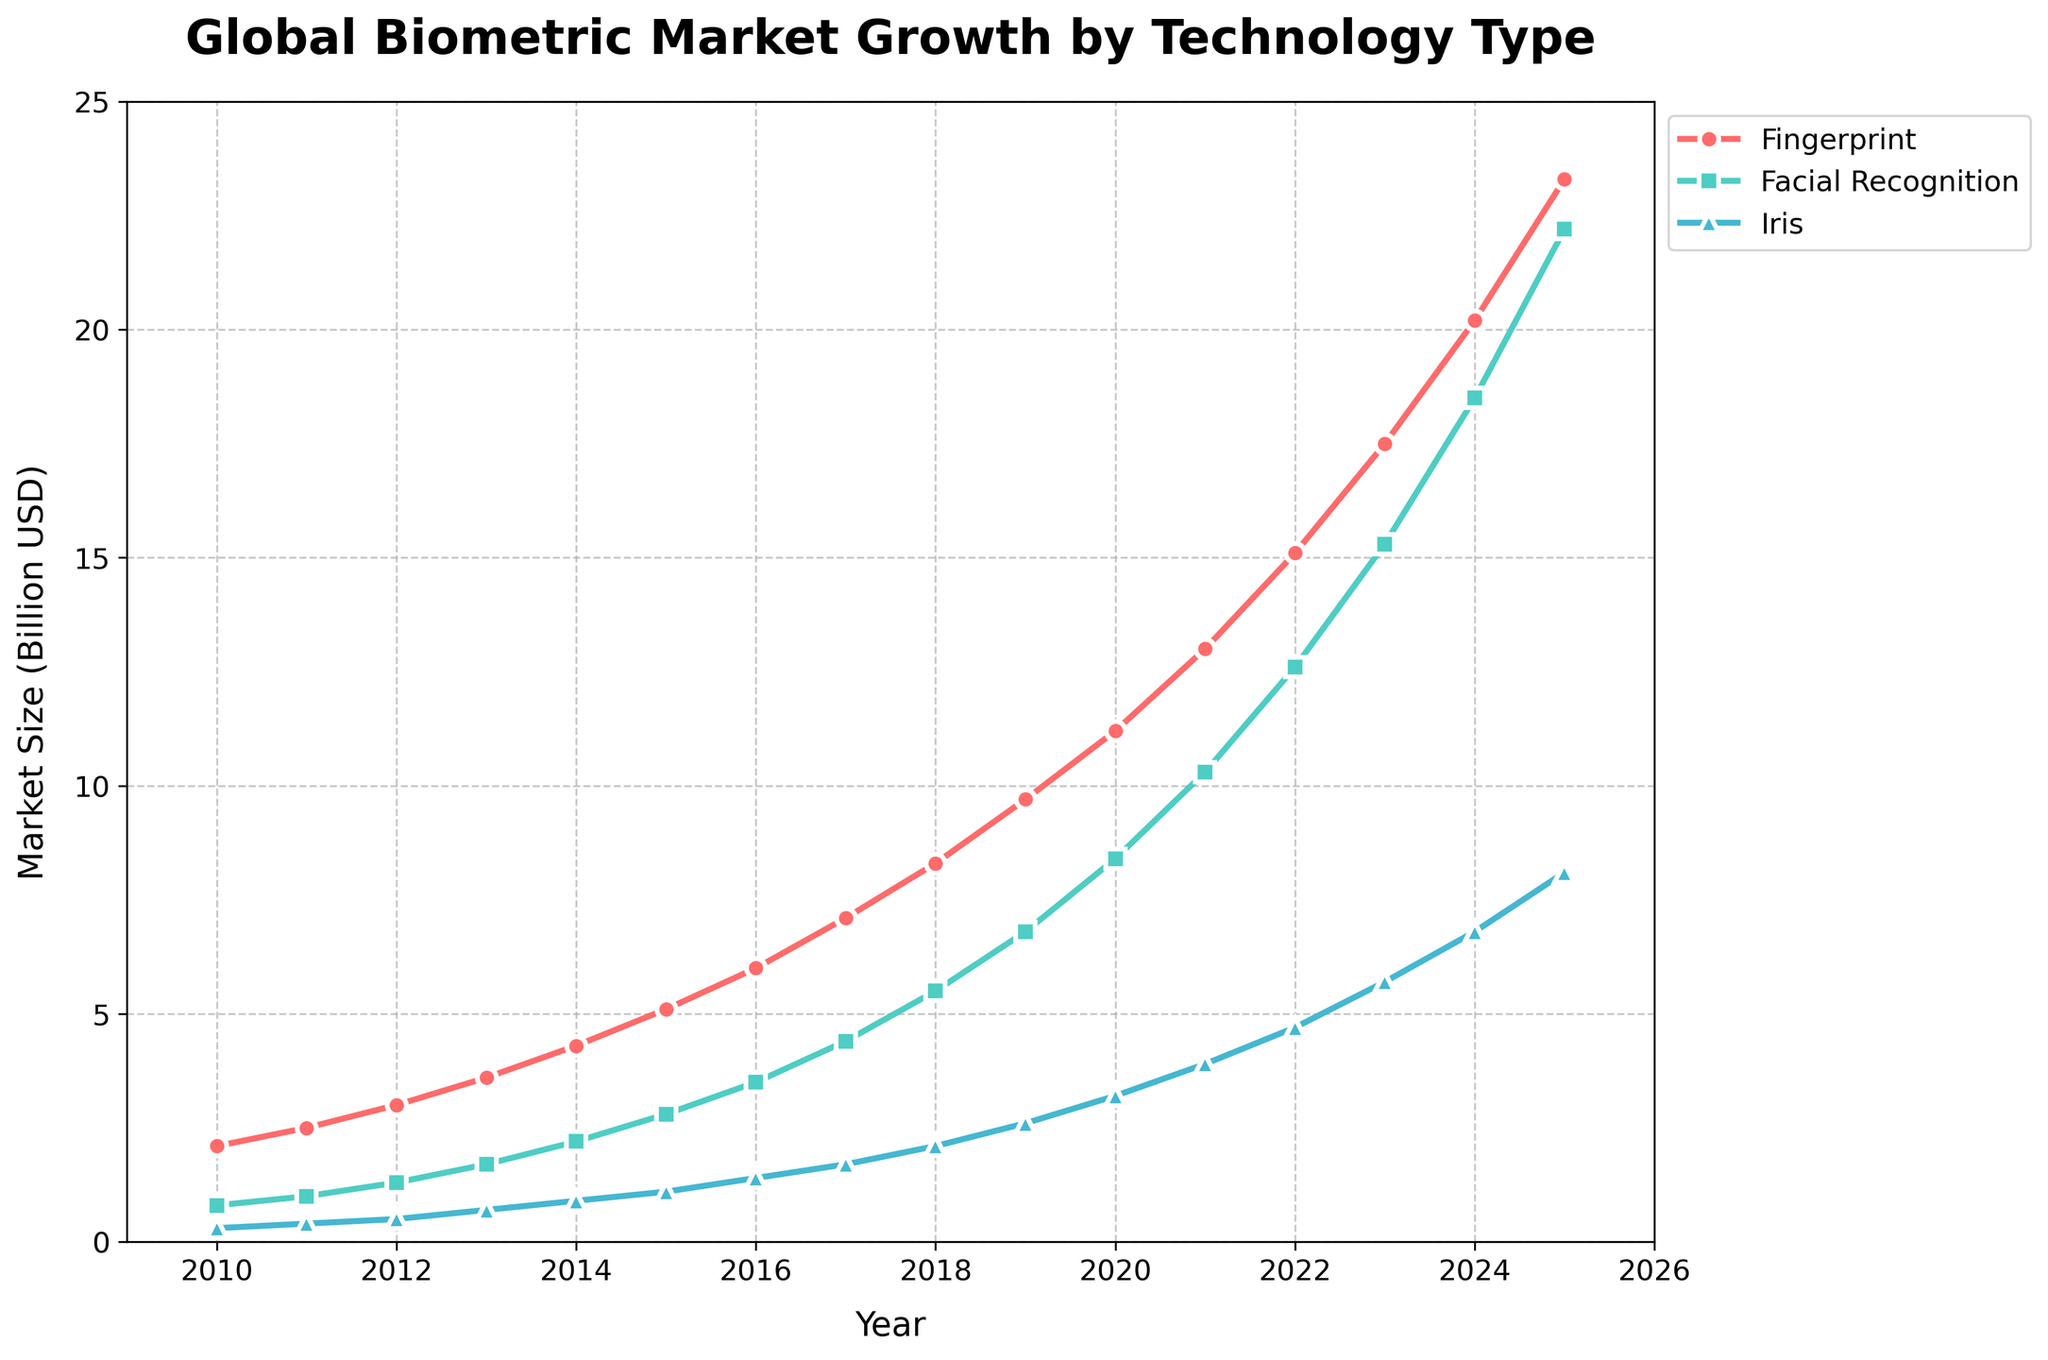How much did the market size for fingerprint technology increase from 2010 to 2020? In 2010, the market size for fingerprint technology was 2.1 billion USD, and by 2020, it was 11.2 billion USD. The increase is 11.2 - 2.1 = 9.1 billion USD.
Answer: 9.1 billion USD Which technology had the largest market size in 2025? In 2025, the market sizes were 23.3 billion USD for fingerprint, 22.2 billion USD for facial recognition, and 8.1 billion USD for iris. Fingerprint technology had the largest market size.
Answer: Fingerprint What was the market size difference between facial recognition and iris technology in 2022? In 2022, the market size for facial recognition was 12.6 billion USD, and for iris, it was 4.7 billion USD. The difference is 12.6 - 4.7 = 7.9 billion USD.
Answer: 7.9 billion USD Which year did facial recognition technology surpass a market size of 10 billion USD? By looking at the gradual increase, facial recognition surpasses 10 billion USD in 2021.
Answer: 2021 In which year did iris technology market size first reach at least 3 billion USD? By observing the line for iris technology, it reached 3 billion USD in 2020.
Answer: 2020 How does the growth of fingerprint technology compare to facial recognition technology between 2010 and 2025? From 2010 to 2025, fingerprint technology grew from 2.1 billion USD to 23.3 billion USD, an increase of 21.2 billion USD. Facial recognition grew from 0.8 billion USD to 22.2 billion USD, an increase of 21.4 billion USD. While both technologies had substantial growth, facial recognition showed a slightly higher increase.
Answer: Both grew substantially, facial recognition had a slightly higher increase What’s the year-over-year growth rate for fingerprint technology from 2019 to 2020? The market size for fingerprint technology in 2019 was 9.7 billion USD and 11.2 billion USD in 2020. The growth rate is (11.2 - 9.7)/9.7 * 100% ≈ 15.46%.
Answer: ≈ 15.46% How many years did it take for the fingerprint technology market size to grow from 2 billion USD to over 10 billion USD? Starting from 2010 with 2.1 billion USD, fingerprint technology surpassed 10 billion USD in 2019. It took 9 years.
Answer: 9 years What is the ratio of the market size of fingerprint technology to iris technology in 2018? In 2018, the market size of fingerprint technology was 8.3 billion USD, and iris technology was 2.1 billion USD. The ratio is 8.3 / 2.1 ≈ 3.95.
Answer: ≈ 3.95 What is the median market size value of facial recognition technology from 2010 to 2025? Arranging the market sizes for facial recognition from 2010 to 2025 (0.8, 1, 1.3, 1.7, 2.2, 2.8, 3.5, 4.4, 5.5, 6.8, 8.4, 10.3, 12.6, 15.3, 18.5, 22.2), the middle value (median) is the average of 3.5 and 4.4, which is (3.5 + 4.4) / 2 = 3.95 billion USD.
Answer: 3.95 billion USD 